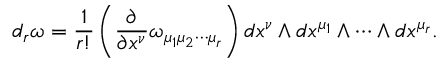Convert formula to latex. <formula><loc_0><loc_0><loc_500><loc_500>d _ { r } \omega = \frac { 1 } { r ! } \left ( \frac { \partial } { \partial x ^ { \nu } } \omega _ { \mu _ { 1 } \mu _ { 2 } \cdots \mu _ { r } } \right ) d x ^ { \nu } \wedge d x ^ { \mu _ { 1 } } \wedge \cdots \wedge d x ^ { \mu _ { r } } .</formula> 